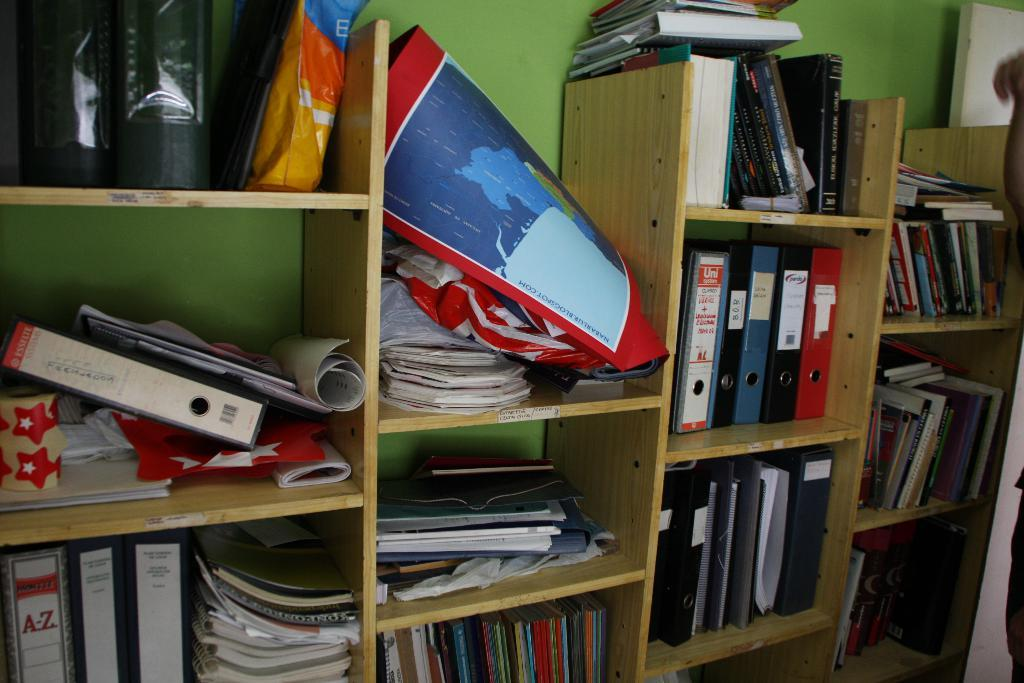<image>
Summarize the visual content of the image. Open wood shelving filled with books and binders. 